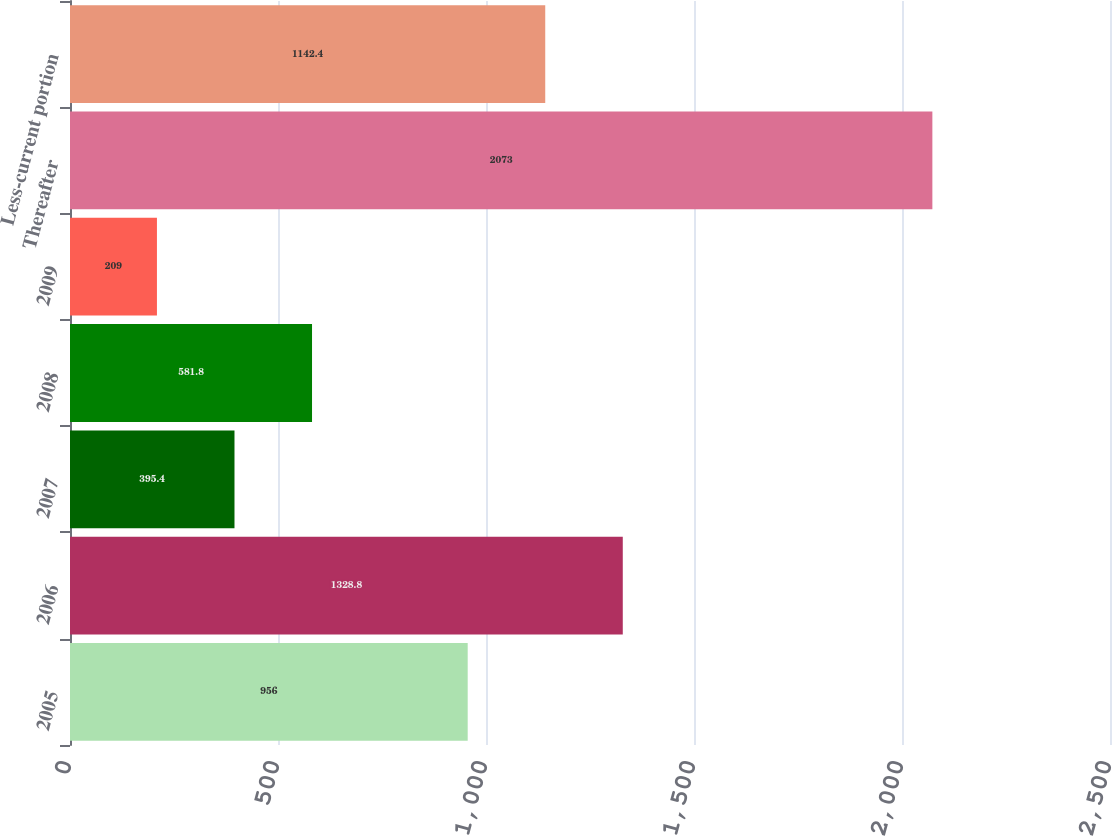<chart> <loc_0><loc_0><loc_500><loc_500><bar_chart><fcel>2005<fcel>2006<fcel>2007<fcel>2008<fcel>2009<fcel>Thereafter<fcel>Less-current portion<nl><fcel>956<fcel>1328.8<fcel>395.4<fcel>581.8<fcel>209<fcel>2073<fcel>1142.4<nl></chart> 